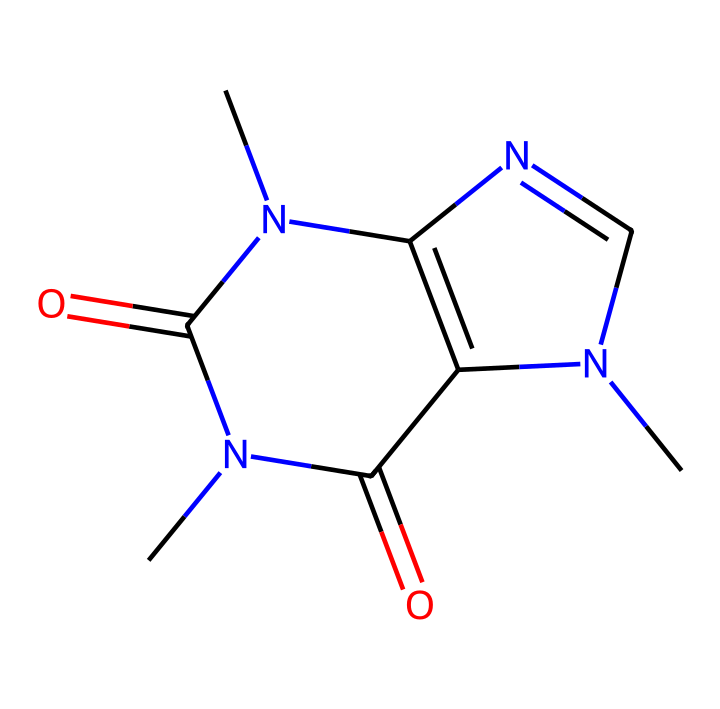What is the molecular formula of caffeine? To determine the molecular formula from the SMILES representation, count the number of carbon (C), hydrogen (H), nitrogen (N), and oxygen (O) atoms. The structure indicates 8 carbons, 10 hydrogens, 4 nitrogens, and 2 oxygens, thus giving us the molecular formula C8H10N4O2.
Answer: C8H10N4O2 How many nitrogen atoms are in caffeine? From the SMILES representation of caffeine, you can easily identify the nitrogen symbols (N). Counting them reveals there are 4 nitrogen atoms present in the structure.
Answer: 4 What general class of compounds does caffeine belong to? Analyzing the structure, caffeine has a composition characteristic of alkaloids due to the presence of nitrogen and its biological effects. Thus, caffeine is classified under alkaloids.
Answer: alkaloid How many rings are present in the caffeine structure? Examining the provided SMILES representation, you can see the presence of two distinct cyclical structures (the nitrogen-containing rings) when depicted as a molecular structure. Hence, caffeine has 2 rings.
Answer: 2 What type of bonding is most prevalent in caffeine? Looking at the structure, most of the atoms are connected by covalent bonds which are typical in organic molecules such as caffeine. Therefore, the predominant type of bonding is covalent.
Answer: covalent What functional groups are present in caffeine? In examining the SMILES code, consider the presence of carbonyl (C=O) groups and amine (N) groups. Caffeine specifically has two amide functional groups in addition to the nitrogen atoms, indicating it includes amides.
Answer: amides What is the total number of atoms in the caffeine molecule? By tallying the total atoms from the molecular formula derived earlier, we have 8 carbons, 10 hydrogens, 4 nitrogens, and 2 oxygens. Summing these gives a total of 24 atoms in caffeine.
Answer: 24 